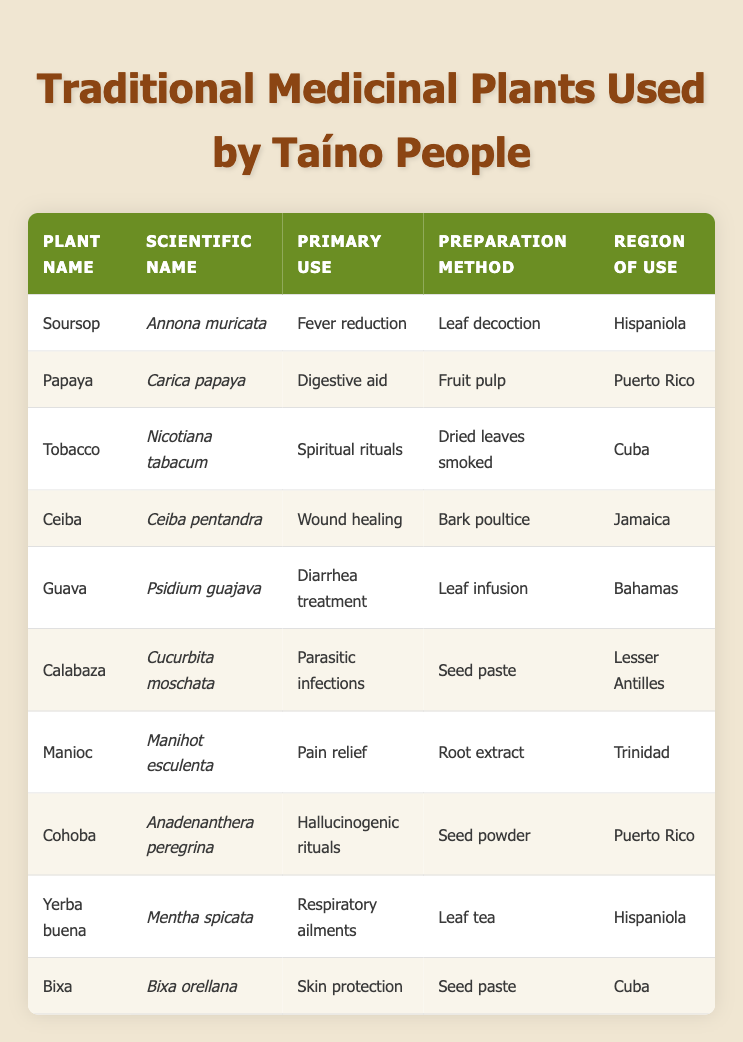What is the scientific name of Soursop? The table lists Soursop in the first row under the "Plant Name" column. Its corresponding scientific name can be found in the "Scientific Name" column of the same row, which is Annona muricata.
Answer: Annona muricata What are the primary uses of plants from Puerto Rico? The table indicates the region of use in the last column. For Puerto Rico, there are two plants: Papaya (Digestive aid) and Cohoba (Hallucinogenic rituals). Thus, the primary uses are digestive aid and hallucinogenic rituals.
Answer: Digestive aid and hallucinogenic rituals Which plant is used for respiratory ailments and what is its preparation method? Looking in the "Primary Use" column, the plant used for respiratory ailments is Yerba buena. Its preparation method can be found in the same row under the "Preparation Method" column, which is leaf tea.
Answer: Yerba buena; leaf tea Is Tobacco used for wound healing? To answer this, we check the "Primary Use" column for Tobacco, which is listed as used in spiritual rituals, not for wound healing. Thus, the answer is no.
Answer: No How many plants are used for skin protection or wound healing? We analyze the "Primary Use" column for relevant entries. Bixa is used for skin protection, and Ceiba is used for wound healing. This gives us a total of two plants.
Answer: 2 What method is used to prepare Guava leaves for diarrhea treatment? The table shows Guava under the "Plant Name" column, with the primary use listed as diarrhea treatment. The preparation method in the same row indicates that the leaves are prepared through a leaf infusion.
Answer: Leaf infusion Which region uses Manioc for pain relief? The "Region of Use" column shows that Manioc is used in Trinidad. Hence, it is directly associated with pain relief in that region.
Answer: Trinidad Which plant has the primary use of fever reduction and how is it prepared? Soursop is used for fever reduction as listed in the "Primary Use" column. The preparation method is leaf decoction as shown in the same row under the "Preparation Method" column.
Answer: Soursop; leaf decoction List the primary uses of all plants from the Lesser Antilles. In the table, locating the Lesser Antilles in the "Region of Use" column, we find Calabaza listed, which is used to treat parasitic infections. Therefore, the primary use for plants from the Lesser Antilles is parasitic infections.
Answer: Parasitic infections 